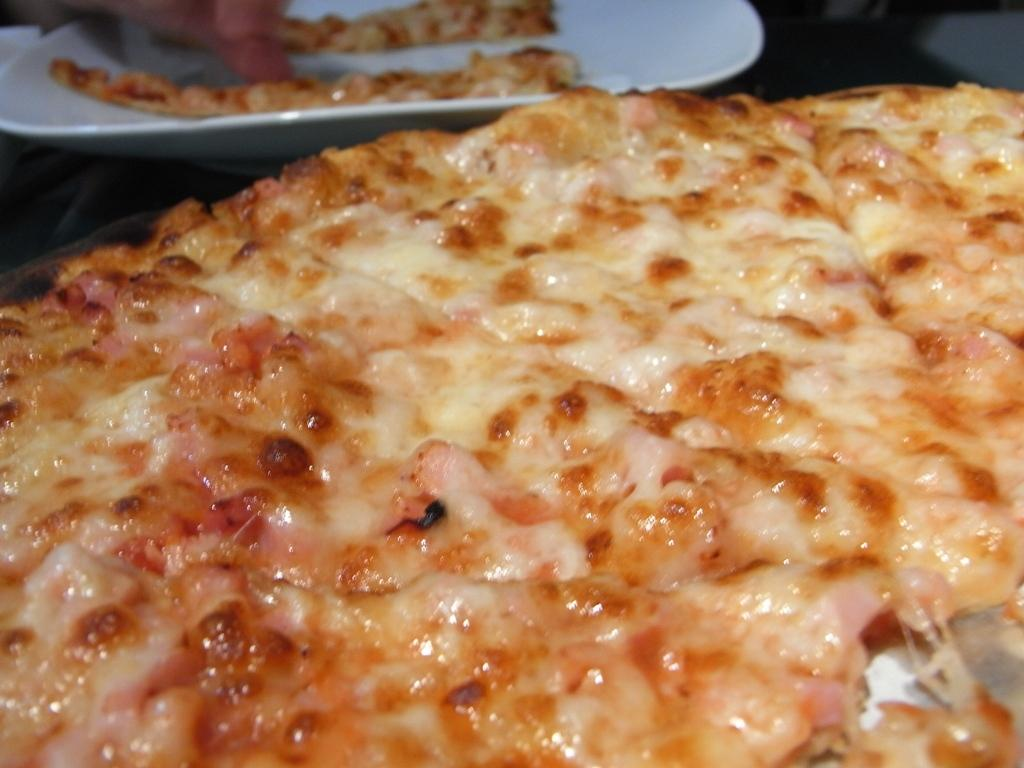What type of food is shown in the image? There is a pizza in the image. What is the pizza placed on? There is a plate in the image. What season is depicted in the image? There is no indication of a season in the image; it only shows a pizza on a plate. 